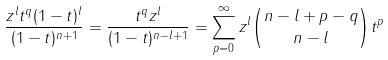<formula> <loc_0><loc_0><loc_500><loc_500>\frac { z ^ { l } t ^ { q } ( 1 - t ) ^ { l } } { ( 1 - t ) ^ { n + 1 } } = \frac { t ^ { q } z ^ { l } } { ( 1 - t ) ^ { n - l + 1 } } = \sum _ { p = 0 } ^ { \infty } z ^ { l } { n - l + p - q \choose n - l } t ^ { p }</formula> 